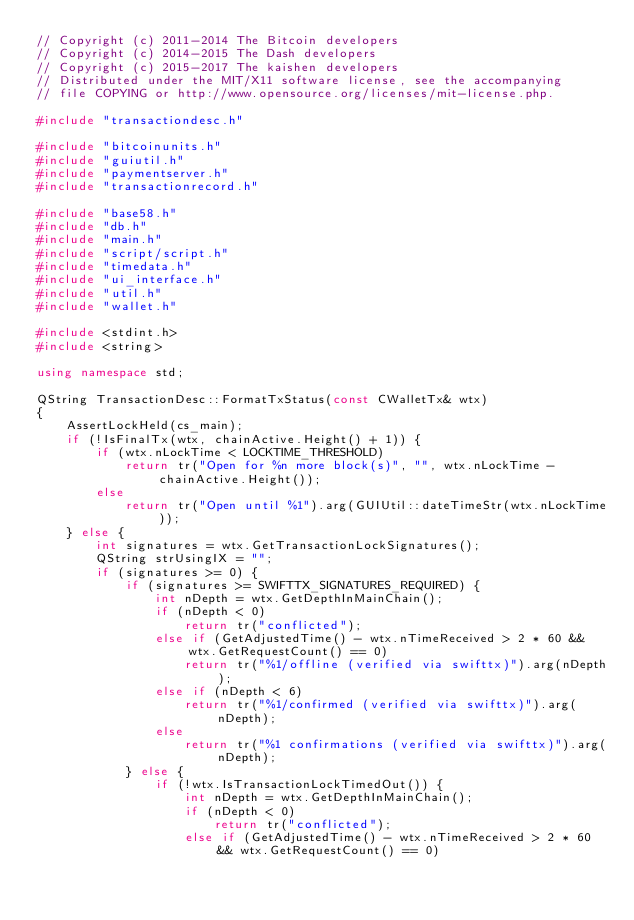<code> <loc_0><loc_0><loc_500><loc_500><_C++_>// Copyright (c) 2011-2014 The Bitcoin developers
// Copyright (c) 2014-2015 The Dash developers
// Copyright (c) 2015-2017 The kaishen developers
// Distributed under the MIT/X11 software license, see the accompanying
// file COPYING or http://www.opensource.org/licenses/mit-license.php.

#include "transactiondesc.h"

#include "bitcoinunits.h"
#include "guiutil.h"
#include "paymentserver.h"
#include "transactionrecord.h"

#include "base58.h"
#include "db.h"
#include "main.h"
#include "script/script.h"
#include "timedata.h"
#include "ui_interface.h"
#include "util.h"
#include "wallet.h"

#include <stdint.h>
#include <string>

using namespace std;

QString TransactionDesc::FormatTxStatus(const CWalletTx& wtx)
{
    AssertLockHeld(cs_main);
    if (!IsFinalTx(wtx, chainActive.Height() + 1)) {
        if (wtx.nLockTime < LOCKTIME_THRESHOLD)
            return tr("Open for %n more block(s)", "", wtx.nLockTime - chainActive.Height());
        else
            return tr("Open until %1").arg(GUIUtil::dateTimeStr(wtx.nLockTime));
    } else {
        int signatures = wtx.GetTransactionLockSignatures();
        QString strUsingIX = "";
        if (signatures >= 0) {
            if (signatures >= SWIFTTX_SIGNATURES_REQUIRED) {
                int nDepth = wtx.GetDepthInMainChain();
                if (nDepth < 0)
                    return tr("conflicted");
                else if (GetAdjustedTime() - wtx.nTimeReceived > 2 * 60 && wtx.GetRequestCount() == 0)
                    return tr("%1/offline (verified via swifttx)").arg(nDepth);
                else if (nDepth < 6)
                    return tr("%1/confirmed (verified via swifttx)").arg(nDepth);
                else
                    return tr("%1 confirmations (verified via swifttx)").arg(nDepth);
            } else {
                if (!wtx.IsTransactionLockTimedOut()) {
                    int nDepth = wtx.GetDepthInMainChain();
                    if (nDepth < 0)
                        return tr("conflicted");
                    else if (GetAdjustedTime() - wtx.nTimeReceived > 2 * 60 && wtx.GetRequestCount() == 0)</code> 